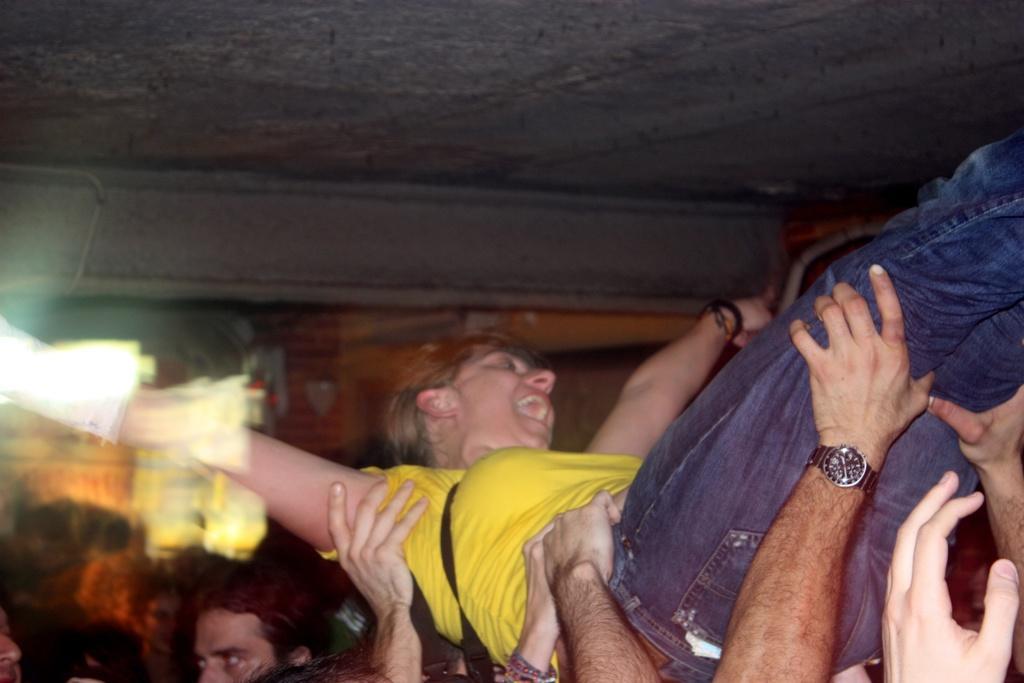Could you give a brief overview of what you see in this image? This is a picture taken in a room, there are group of people holding a woman. The woman is in yellow t shirt with blue jeans. Behind the woman there is a wall and on to there is a roof. 